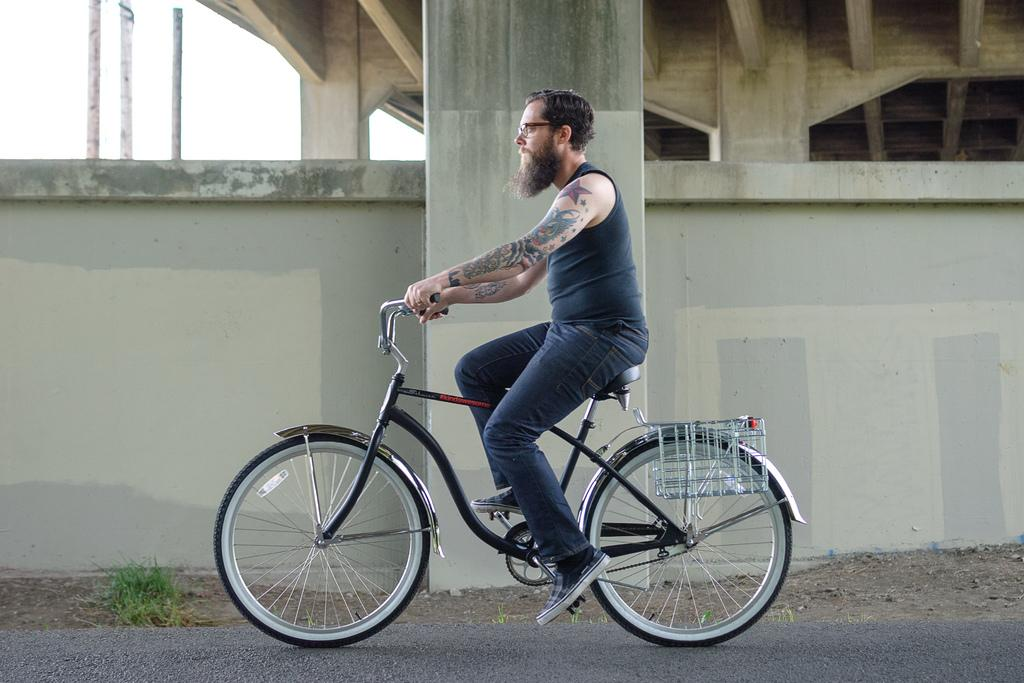What is the man in the image doing? The man is riding a bicycle in the image. How is the man controlling the bicycle? The man is holding the handle of the bicycle. What can be seen in the background of the image? There is a pillar and a plant on the ground in the image. What distinguishing feature does the man have on his hands? The man has a tattoo on his hands. What song is the man singing while riding the bicycle in the image? There is no indication in the image that the man is singing a song, so it cannot be determined from the picture. 